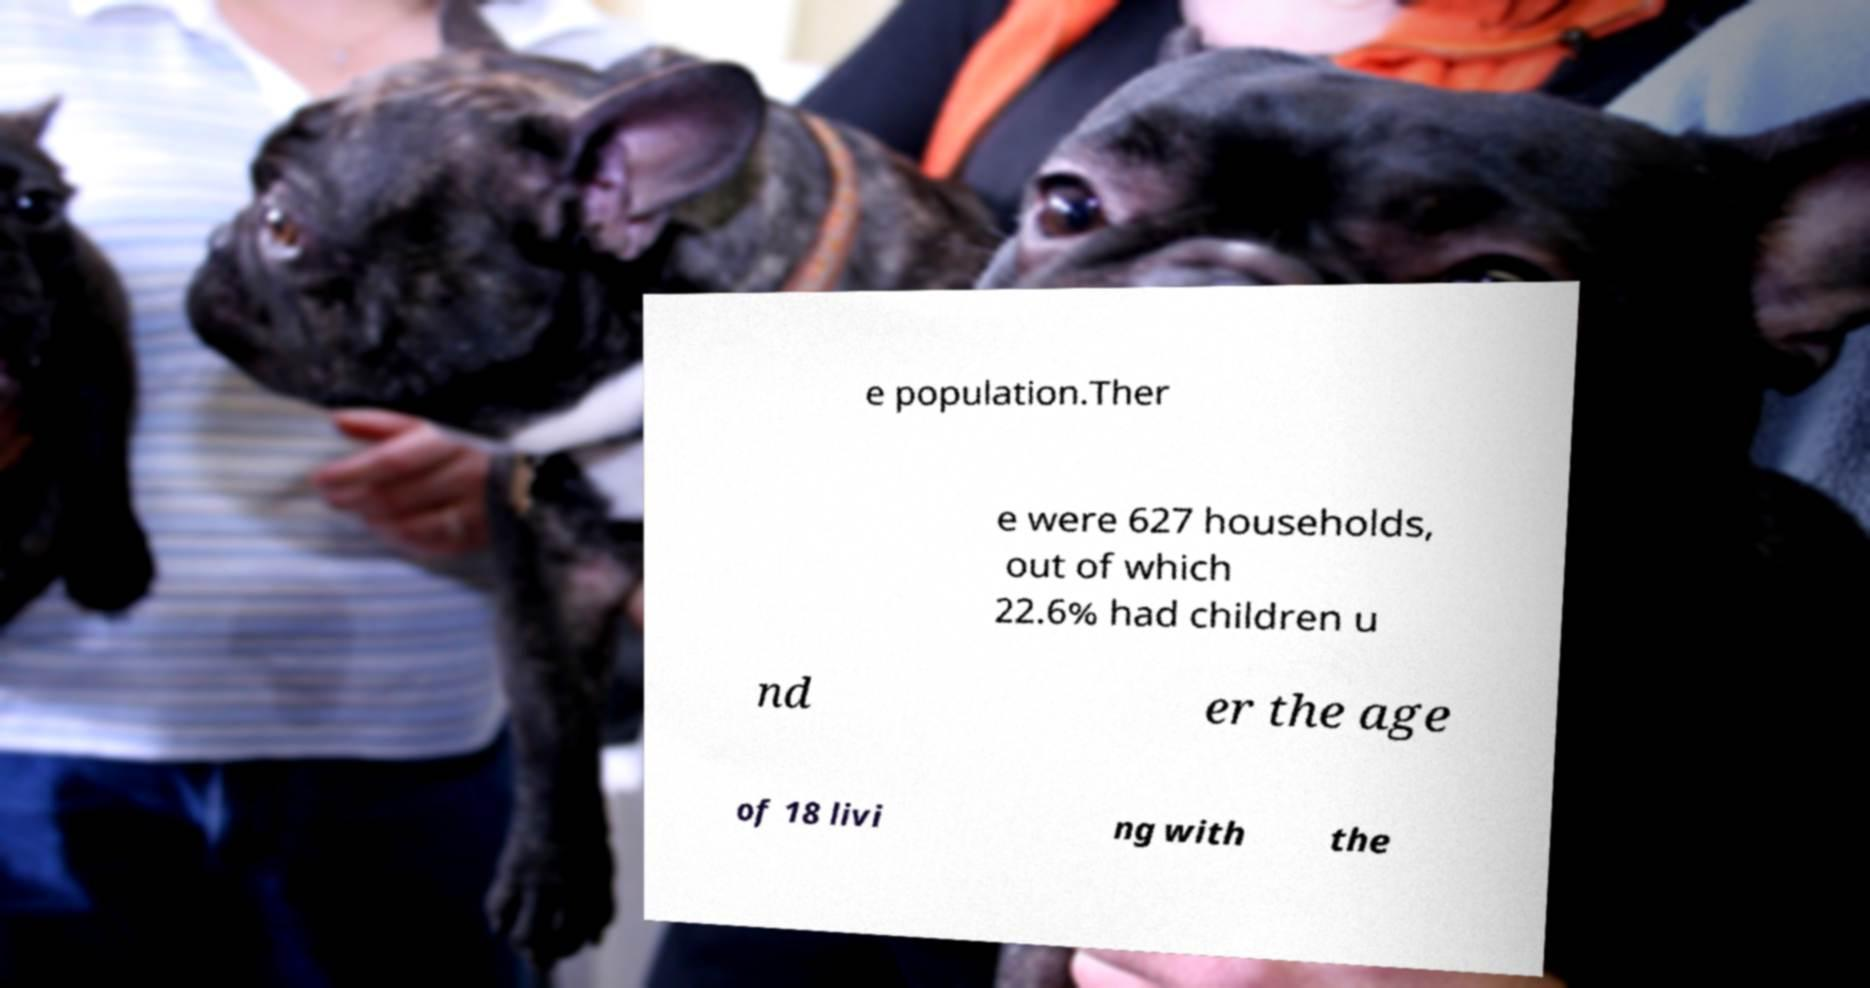Can you read and provide the text displayed in the image?This photo seems to have some interesting text. Can you extract and type it out for me? e population.Ther e were 627 households, out of which 22.6% had children u nd er the age of 18 livi ng with the 